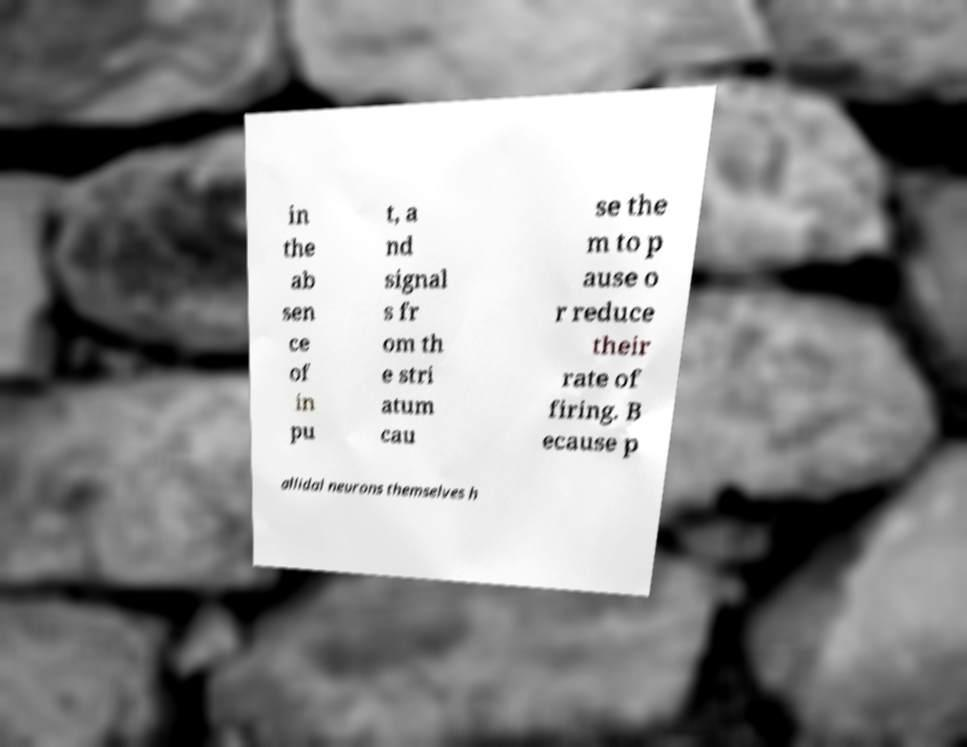What messages or text are displayed in this image? I need them in a readable, typed format. in the ab sen ce of in pu t, a nd signal s fr om th e stri atum cau se the m to p ause o r reduce their rate of firing. B ecause p allidal neurons themselves h 